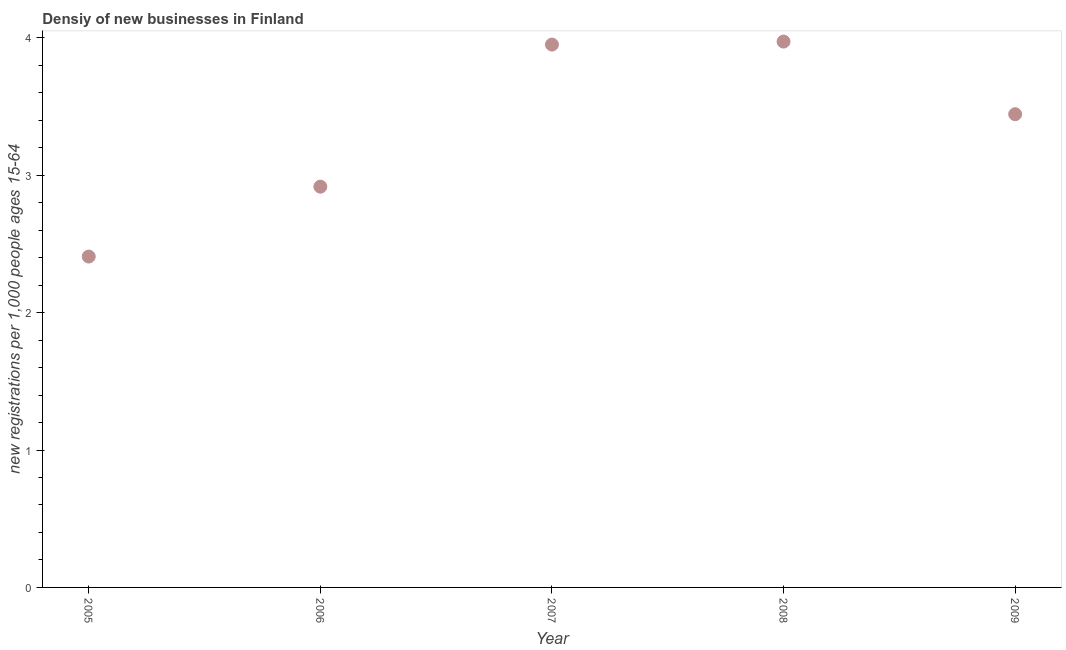What is the density of new business in 2005?
Your response must be concise. 2.41. Across all years, what is the maximum density of new business?
Your response must be concise. 3.97. Across all years, what is the minimum density of new business?
Make the answer very short. 2.41. What is the sum of the density of new business?
Provide a succinct answer. 16.69. What is the difference between the density of new business in 2007 and 2008?
Offer a very short reply. -0.02. What is the average density of new business per year?
Provide a succinct answer. 3.34. What is the median density of new business?
Your response must be concise. 3.44. What is the ratio of the density of new business in 2006 to that in 2007?
Your answer should be very brief. 0.74. What is the difference between the highest and the second highest density of new business?
Provide a short and direct response. 0.02. Is the sum of the density of new business in 2007 and 2008 greater than the maximum density of new business across all years?
Provide a succinct answer. Yes. What is the difference between the highest and the lowest density of new business?
Offer a terse response. 1.56. In how many years, is the density of new business greater than the average density of new business taken over all years?
Provide a succinct answer. 3. Does the density of new business monotonically increase over the years?
Offer a very short reply. No. What is the title of the graph?
Provide a short and direct response. Densiy of new businesses in Finland. What is the label or title of the X-axis?
Ensure brevity in your answer.  Year. What is the label or title of the Y-axis?
Offer a very short reply. New registrations per 1,0 people ages 15-64. What is the new registrations per 1,000 people ages 15-64 in 2005?
Offer a very short reply. 2.41. What is the new registrations per 1,000 people ages 15-64 in 2006?
Give a very brief answer. 2.92. What is the new registrations per 1,000 people ages 15-64 in 2007?
Offer a very short reply. 3.95. What is the new registrations per 1,000 people ages 15-64 in 2008?
Your answer should be compact. 3.97. What is the new registrations per 1,000 people ages 15-64 in 2009?
Provide a succinct answer. 3.44. What is the difference between the new registrations per 1,000 people ages 15-64 in 2005 and 2006?
Ensure brevity in your answer.  -0.51. What is the difference between the new registrations per 1,000 people ages 15-64 in 2005 and 2007?
Offer a very short reply. -1.54. What is the difference between the new registrations per 1,000 people ages 15-64 in 2005 and 2008?
Your answer should be very brief. -1.56. What is the difference between the new registrations per 1,000 people ages 15-64 in 2005 and 2009?
Offer a very short reply. -1.04. What is the difference between the new registrations per 1,000 people ages 15-64 in 2006 and 2007?
Give a very brief answer. -1.03. What is the difference between the new registrations per 1,000 people ages 15-64 in 2006 and 2008?
Ensure brevity in your answer.  -1.06. What is the difference between the new registrations per 1,000 people ages 15-64 in 2006 and 2009?
Offer a terse response. -0.53. What is the difference between the new registrations per 1,000 people ages 15-64 in 2007 and 2008?
Ensure brevity in your answer.  -0.02. What is the difference between the new registrations per 1,000 people ages 15-64 in 2007 and 2009?
Make the answer very short. 0.51. What is the difference between the new registrations per 1,000 people ages 15-64 in 2008 and 2009?
Offer a very short reply. 0.53. What is the ratio of the new registrations per 1,000 people ages 15-64 in 2005 to that in 2006?
Your answer should be compact. 0.83. What is the ratio of the new registrations per 1,000 people ages 15-64 in 2005 to that in 2007?
Give a very brief answer. 0.61. What is the ratio of the new registrations per 1,000 people ages 15-64 in 2005 to that in 2008?
Offer a terse response. 0.61. What is the ratio of the new registrations per 1,000 people ages 15-64 in 2005 to that in 2009?
Give a very brief answer. 0.7. What is the ratio of the new registrations per 1,000 people ages 15-64 in 2006 to that in 2007?
Keep it short and to the point. 0.74. What is the ratio of the new registrations per 1,000 people ages 15-64 in 2006 to that in 2008?
Give a very brief answer. 0.73. What is the ratio of the new registrations per 1,000 people ages 15-64 in 2006 to that in 2009?
Keep it short and to the point. 0.85. What is the ratio of the new registrations per 1,000 people ages 15-64 in 2007 to that in 2008?
Ensure brevity in your answer.  0.99. What is the ratio of the new registrations per 1,000 people ages 15-64 in 2007 to that in 2009?
Provide a succinct answer. 1.15. What is the ratio of the new registrations per 1,000 people ages 15-64 in 2008 to that in 2009?
Your response must be concise. 1.15. 